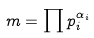Convert formula to latex. <formula><loc_0><loc_0><loc_500><loc_500>m = \prod p _ { i } ^ { \alpha _ { i } }</formula> 